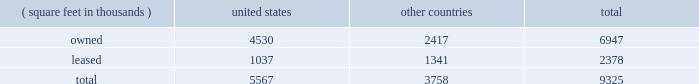Item 2 : properties information concerning applied 2019s properties is set forth below: .
Because of the interrelation of applied 2019s operations , properties within a country may be shared by the segments operating within that country .
The company 2019s headquarters offices are in santa clara , california .
Products in semiconductor systems are manufactured in santa clara , california ; austin , texas ; gloucester , massachusetts ; kalispell , montana ; rehovot , israel ; and singapore .
Remanufactured equipment products in the applied global services segment are produced primarily in austin , texas .
Products in the display and adjacent markets segment are manufactured in alzenau , germany and tainan , taiwan .
Other products are manufactured in treviso , italy .
Applied also owns and leases offices , plants and warehouse locations in many locations throughout the world , including in europe , japan , north america ( principally the united states ) , israel , china , india , korea , southeast asia and taiwan .
These facilities are principally used for manufacturing ; research , development and engineering ; and marketing , sales and customer support .
Applied also owns a total of approximately 269 acres of buildable land in montana , texas , california , israel and italy that could accommodate additional building space .
Applied considers the properties that it owns or leases as adequate to meet its current and future requirements .
Applied regularly assesses the size , capability and location of its global infrastructure and periodically makes adjustments based on these assessments. .
What portion of total company used area is company owned? 
Computations: (6947 / 9325)
Answer: 0.74499. 